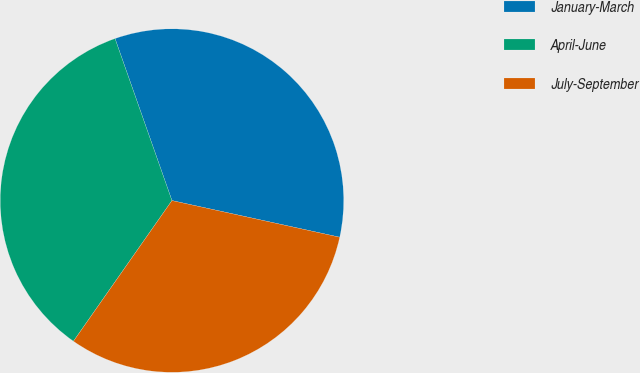<chart> <loc_0><loc_0><loc_500><loc_500><pie_chart><fcel>January-March<fcel>April-June<fcel>July-September<nl><fcel>33.8%<fcel>34.9%<fcel>31.3%<nl></chart> 